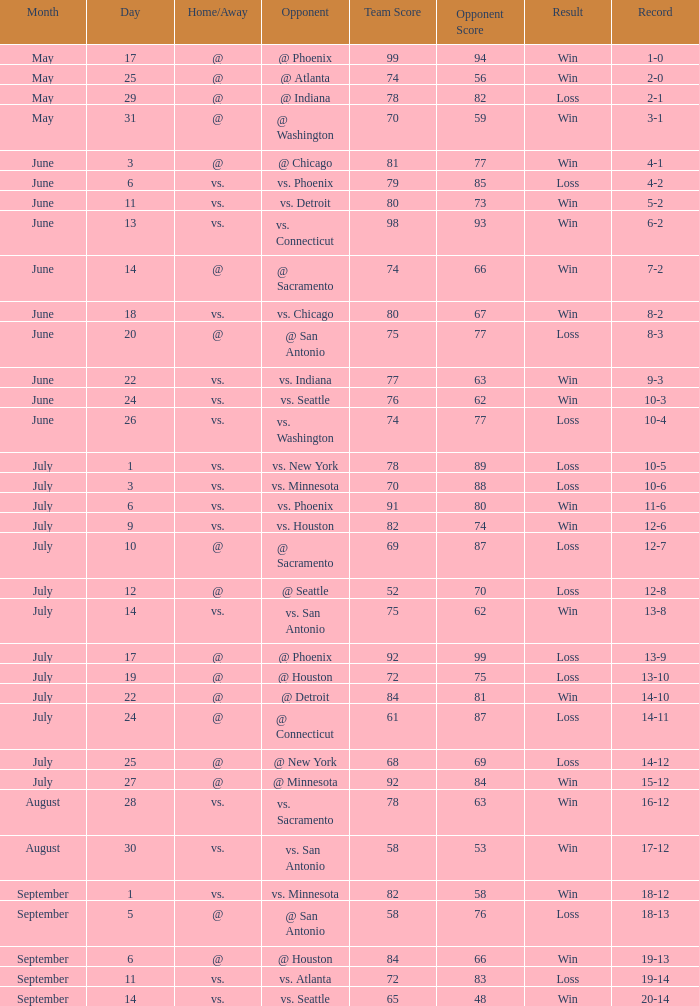What is the Opponent of the game with a Score of 74-66? @ Sacramento. 